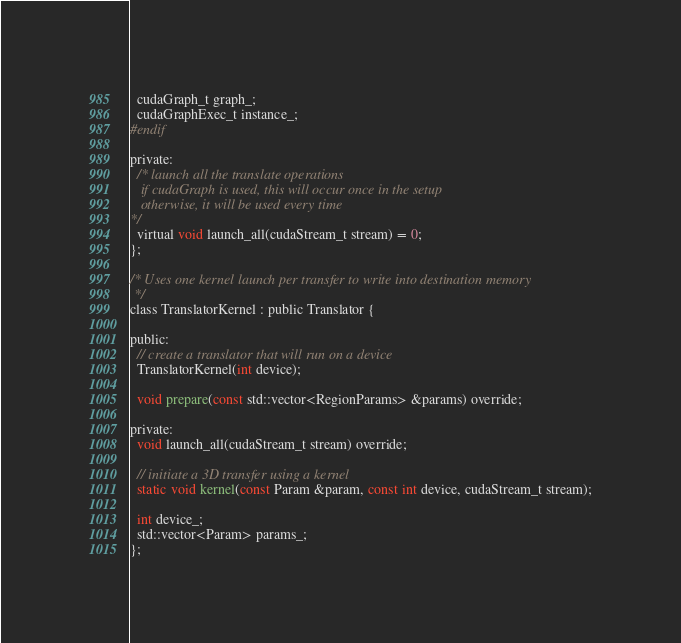<code> <loc_0><loc_0><loc_500><loc_500><_Cuda_>  cudaGraph_t graph_;
  cudaGraphExec_t instance_;
#endif

private:
  /* launch all the translate operations
   if cudaGraph is used, this will occur once in the setup
   otherwise, it will be used every time
*/
  virtual void launch_all(cudaStream_t stream) = 0;
};

/* Uses one kernel launch per transfer to write into destination memory
 */
class TranslatorKernel : public Translator {

public:
  // create a translator that will run on a device
  TranslatorKernel(int device);

  void prepare(const std::vector<RegionParams> &params) override;

private:
  void launch_all(cudaStream_t stream) override;

  // initiate a 3D transfer using a kernel
  static void kernel(const Param &param, const int device, cudaStream_t stream);

  int device_;
  std::vector<Param> params_;
};
</code> 